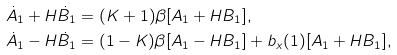Convert formula to latex. <formula><loc_0><loc_0><loc_500><loc_500>\dot { A } _ { 1 } + H \dot { B } _ { 1 } & = ( K + 1 ) \beta [ A _ { 1 } + H B _ { 1 } ] , \\ \dot { A } _ { 1 } - H \dot { B } _ { 1 } & = ( 1 - K ) \beta [ A _ { 1 } - H B _ { 1 } ] + b _ { x } ( 1 ) [ A _ { 1 } + H B _ { 1 } ] ,</formula> 